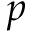<formula> <loc_0><loc_0><loc_500><loc_500>p</formula> 